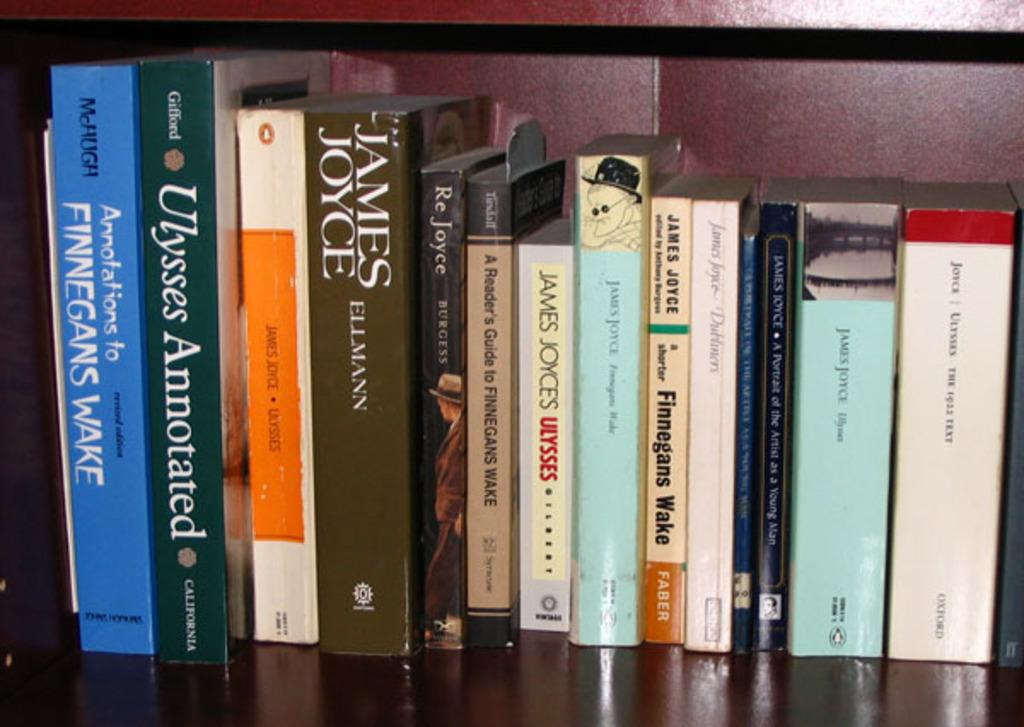<image>
Render a clear and concise summary of the photo. One of the books on the shelf by James Joyce is called Ulysses. 